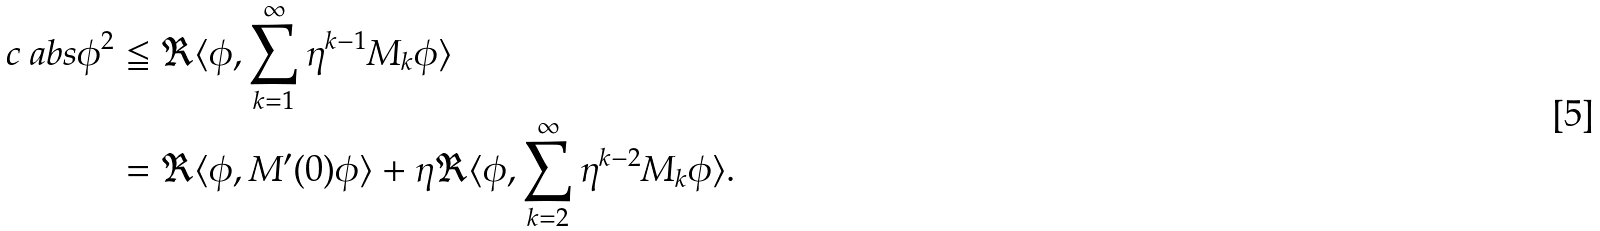Convert formula to latex. <formula><loc_0><loc_0><loc_500><loc_500>c \ a b s { \phi } ^ { 2 } & \leqq \Re \langle \phi , \sum _ { k = 1 } ^ { \infty } \eta ^ { k - 1 } M _ { k } \phi \rangle \\ & = \Re \langle \phi , M ^ { \prime } ( 0 ) \phi \rangle + \eta \Re \langle \phi , \sum _ { k = 2 } ^ { \infty } \eta ^ { k - 2 } M _ { k } \phi \rangle .</formula> 